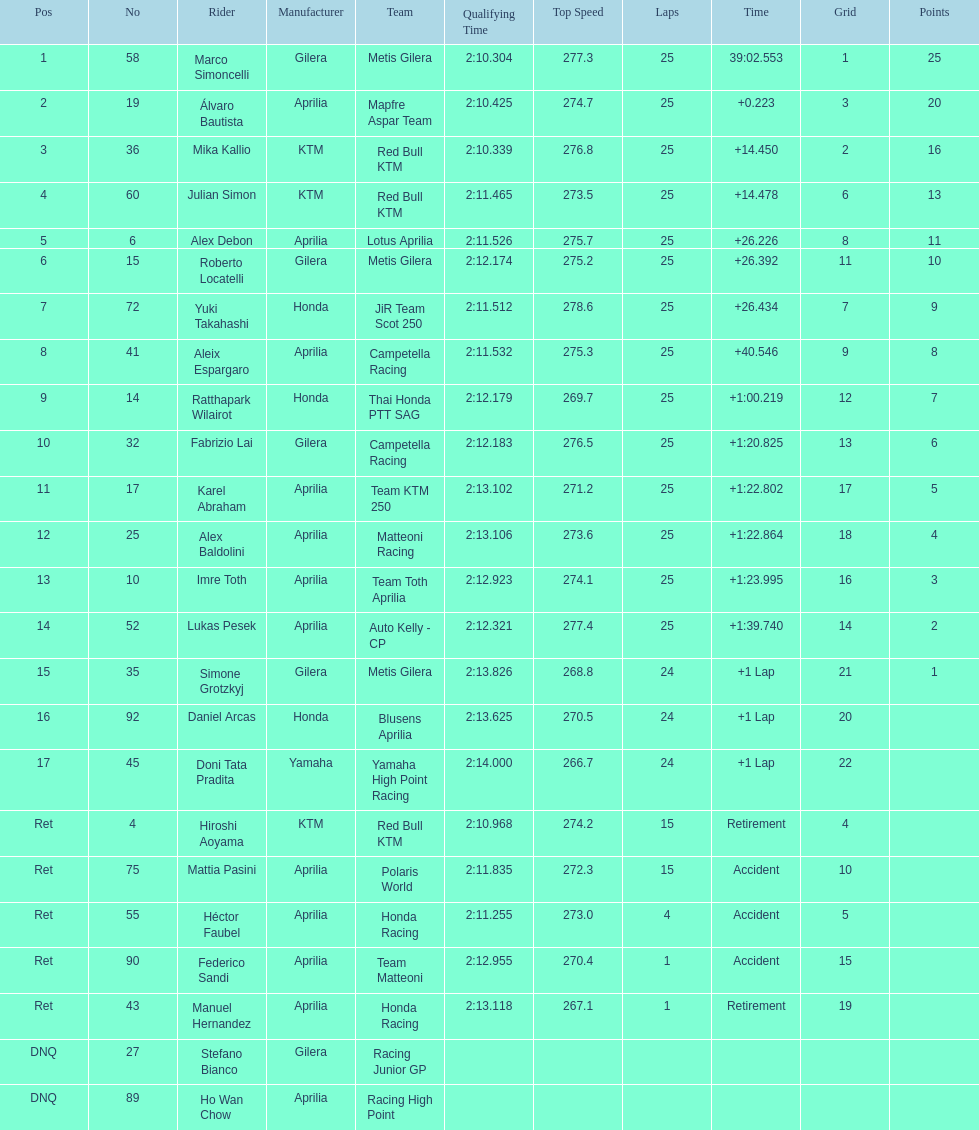What is the total number of rider? 24. 